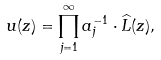<formula> <loc_0><loc_0><loc_500><loc_500>u ( z ) = \prod _ { j = 1 } ^ { \infty } a _ { j } ^ { - 1 } \cdot \widehat { L } ( z ) ,</formula> 